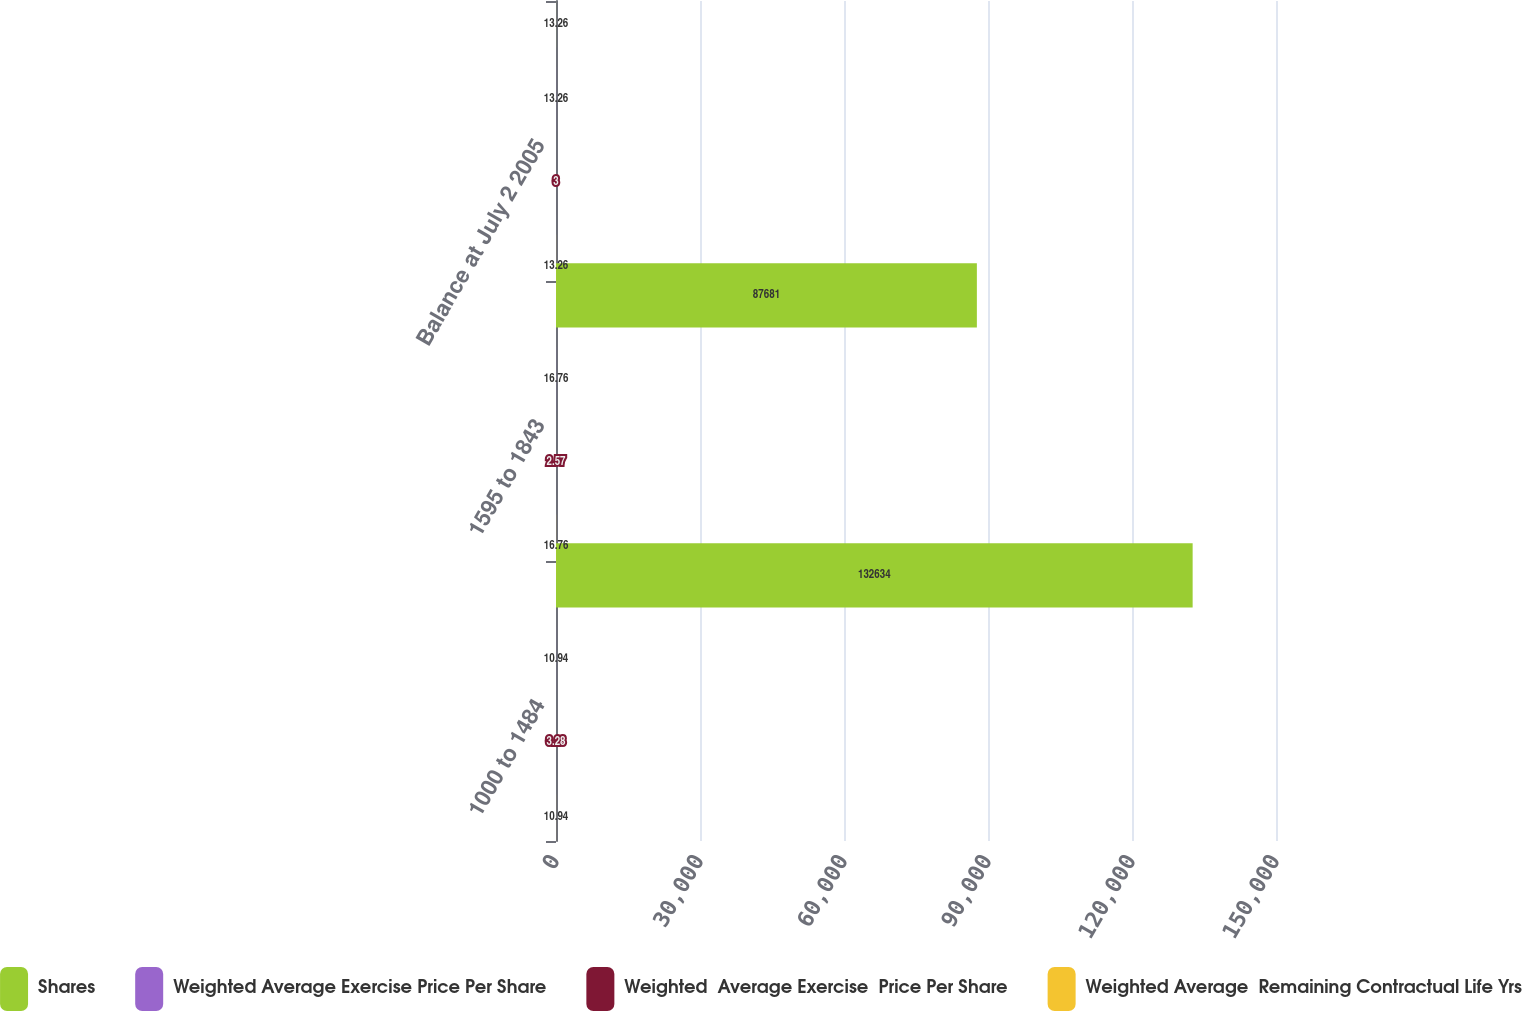Convert chart. <chart><loc_0><loc_0><loc_500><loc_500><stacked_bar_chart><ecel><fcel>1000 to 1484<fcel>1595 to 1843<fcel>Balance at July 2 2005<nl><fcel>Shares<fcel>132634<fcel>87681<fcel>13.26<nl><fcel>Weighted Average Exercise Price Per Share<fcel>10.94<fcel>16.76<fcel>13.26<nl><fcel>Weighted  Average Exercise  Price Per Share<fcel>3.28<fcel>2.57<fcel>3<nl><fcel>Weighted Average  Remaining Contractual Life Yrs<fcel>10.94<fcel>16.76<fcel>13.26<nl></chart> 